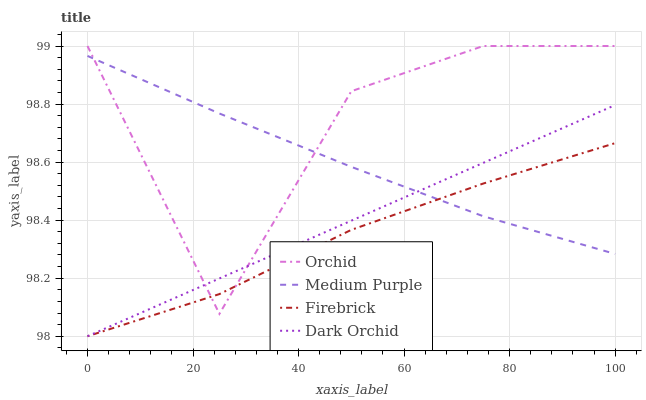Does Firebrick have the minimum area under the curve?
Answer yes or no. Yes. Does Orchid have the maximum area under the curve?
Answer yes or no. Yes. Does Dark Orchid have the minimum area under the curve?
Answer yes or no. No. Does Dark Orchid have the maximum area under the curve?
Answer yes or no. No. Is Dark Orchid the smoothest?
Answer yes or no. Yes. Is Orchid the roughest?
Answer yes or no. Yes. Is Firebrick the smoothest?
Answer yes or no. No. Is Firebrick the roughest?
Answer yes or no. No. Does Firebrick have the lowest value?
Answer yes or no. Yes. Does Orchid have the lowest value?
Answer yes or no. No. Does Orchid have the highest value?
Answer yes or no. Yes. Does Dark Orchid have the highest value?
Answer yes or no. No. Does Firebrick intersect Dark Orchid?
Answer yes or no. Yes. Is Firebrick less than Dark Orchid?
Answer yes or no. No. Is Firebrick greater than Dark Orchid?
Answer yes or no. No. 